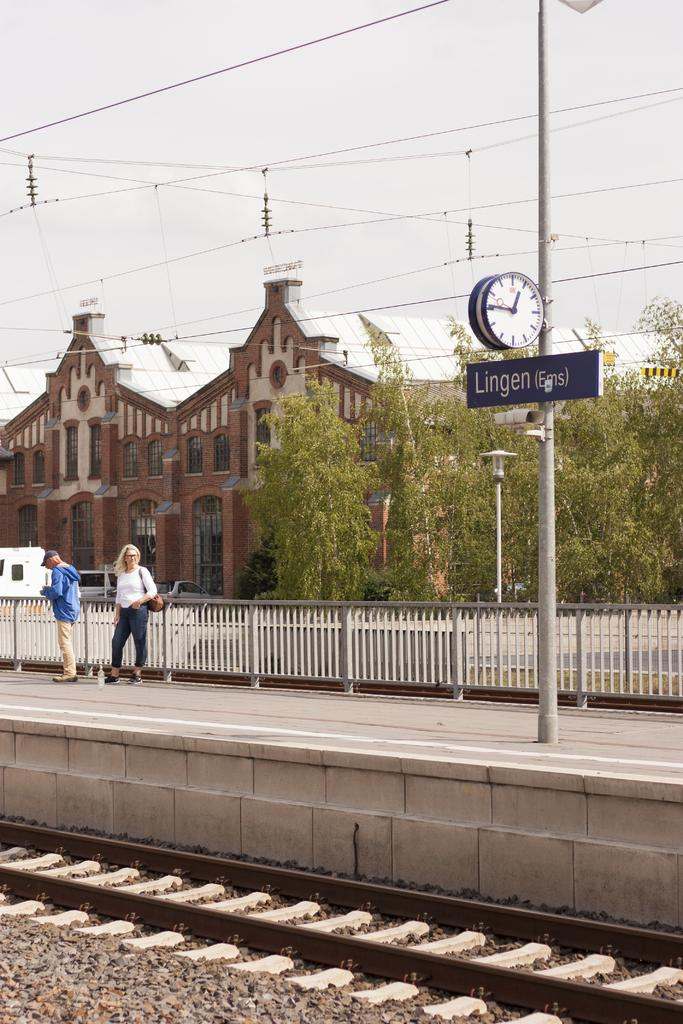Provide a one-sentence caption for the provided image. Two women at the Lingen train station waiting for a train during the day. 